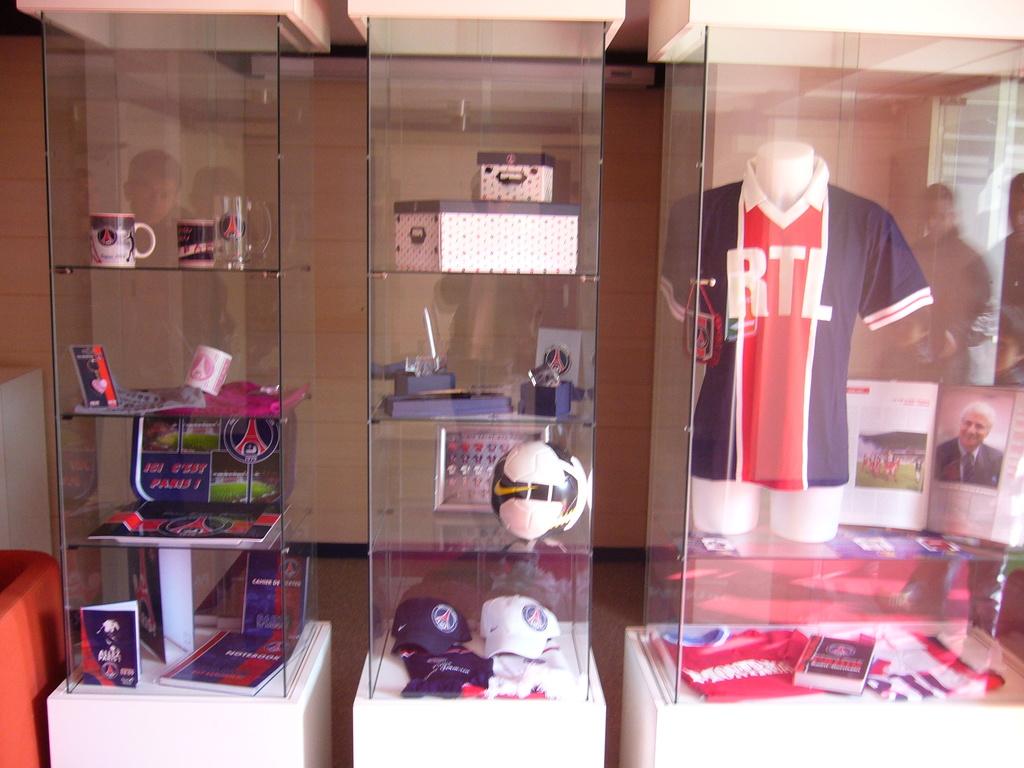What is written on the jersey in the glass case?
Keep it short and to the point. Rtl. 